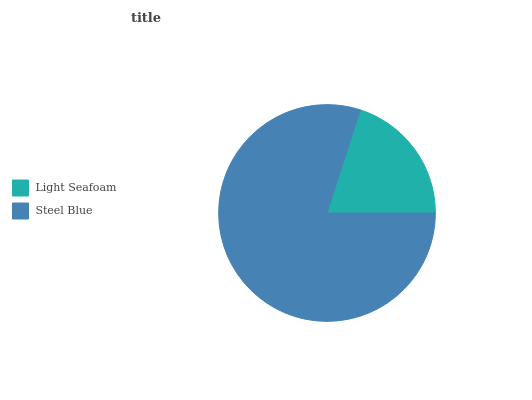Is Light Seafoam the minimum?
Answer yes or no. Yes. Is Steel Blue the maximum?
Answer yes or no. Yes. Is Steel Blue the minimum?
Answer yes or no. No. Is Steel Blue greater than Light Seafoam?
Answer yes or no. Yes. Is Light Seafoam less than Steel Blue?
Answer yes or no. Yes. Is Light Seafoam greater than Steel Blue?
Answer yes or no. No. Is Steel Blue less than Light Seafoam?
Answer yes or no. No. Is Steel Blue the high median?
Answer yes or no. Yes. Is Light Seafoam the low median?
Answer yes or no. Yes. Is Light Seafoam the high median?
Answer yes or no. No. Is Steel Blue the low median?
Answer yes or no. No. 